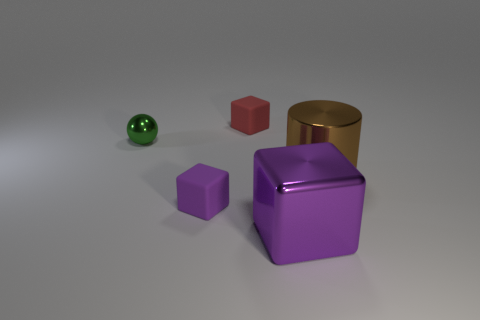How big is the metal thing that is left of the matte cube behind the purple thing to the left of the purple metal object?
Give a very brief answer. Small. There is a green thing that is made of the same material as the big cylinder; what is its size?
Provide a short and direct response. Small. What number of small objects are shiny cylinders or rubber things?
Offer a very short reply. 2. There is another rubber object that is the same size as the purple matte thing; what color is it?
Keep it short and to the point. Red. How many other things are there of the same shape as the big brown shiny object?
Provide a succinct answer. 0. Is there a big brown object made of the same material as the small green ball?
Provide a succinct answer. Yes. Is the purple object left of the large purple metallic block made of the same material as the large purple thing that is in front of the tiny green sphere?
Provide a succinct answer. No. How many tiny spheres are there?
Your response must be concise. 1. What is the shape of the matte object that is in front of the red rubber object?
Offer a terse response. Cube. What number of other objects are there of the same size as the red cube?
Keep it short and to the point. 2. 